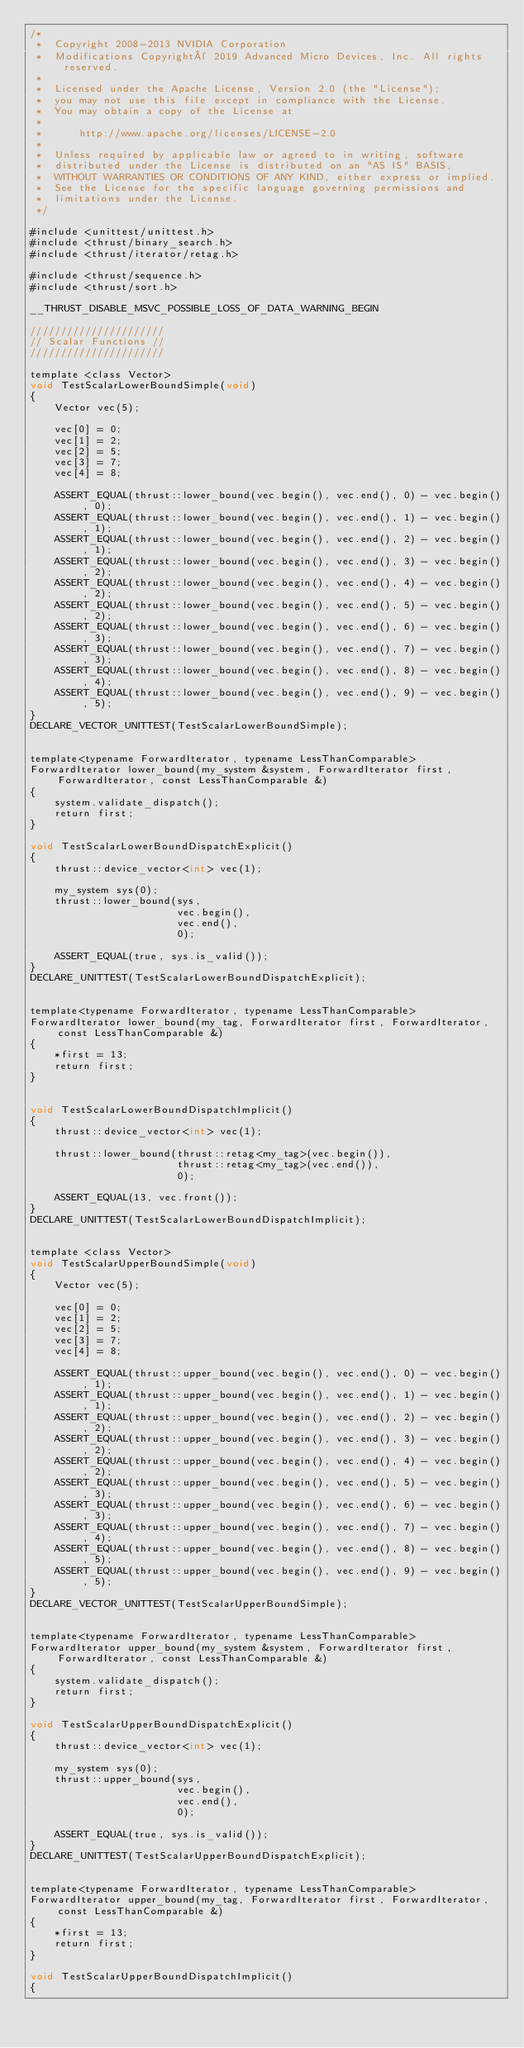Convert code to text. <code><loc_0><loc_0><loc_500><loc_500><_Cuda_>/*
 *  Copyright 2008-2013 NVIDIA Corporation
 *  Modifications Copyright© 2019 Advanced Micro Devices, Inc. All rights reserved.
 *
 *  Licensed under the Apache License, Version 2.0 (the "License");
 *  you may not use this file except in compliance with the License.
 *  You may obtain a copy of the License at
 *
 *      http://www.apache.org/licenses/LICENSE-2.0
 *
 *  Unless required by applicable law or agreed to in writing, software
 *  distributed under the License is distributed on an "AS IS" BASIS,
 *  WITHOUT WARRANTIES OR CONDITIONS OF ANY KIND, either express or implied.
 *  See the License for the specific language governing permissions and
 *  limitations under the License.
 */
 
#include <unittest/unittest.h>
#include <thrust/binary_search.h>
#include <thrust/iterator/retag.h>

#include <thrust/sequence.h>
#include <thrust/sort.h>

__THRUST_DISABLE_MSVC_POSSIBLE_LOSS_OF_DATA_WARNING_BEGIN

//////////////////////
// Scalar Functions //
//////////////////////

template <class Vector>
void TestScalarLowerBoundSimple(void)
{
    Vector vec(5);

    vec[0] = 0;
    vec[1] = 2;
    vec[2] = 5;
    vec[3] = 7;
    vec[4] = 8;

    ASSERT_EQUAL(thrust::lower_bound(vec.begin(), vec.end(), 0) - vec.begin(), 0);
    ASSERT_EQUAL(thrust::lower_bound(vec.begin(), vec.end(), 1) - vec.begin(), 1);
    ASSERT_EQUAL(thrust::lower_bound(vec.begin(), vec.end(), 2) - vec.begin(), 1);
    ASSERT_EQUAL(thrust::lower_bound(vec.begin(), vec.end(), 3) - vec.begin(), 2);
    ASSERT_EQUAL(thrust::lower_bound(vec.begin(), vec.end(), 4) - vec.begin(), 2);
    ASSERT_EQUAL(thrust::lower_bound(vec.begin(), vec.end(), 5) - vec.begin(), 2);
    ASSERT_EQUAL(thrust::lower_bound(vec.begin(), vec.end(), 6) - vec.begin(), 3);
    ASSERT_EQUAL(thrust::lower_bound(vec.begin(), vec.end(), 7) - vec.begin(), 3);
    ASSERT_EQUAL(thrust::lower_bound(vec.begin(), vec.end(), 8) - vec.begin(), 4);
    ASSERT_EQUAL(thrust::lower_bound(vec.begin(), vec.end(), 9) - vec.begin(), 5);
}
DECLARE_VECTOR_UNITTEST(TestScalarLowerBoundSimple);


template<typename ForwardIterator, typename LessThanComparable>
ForwardIterator lower_bound(my_system &system, ForwardIterator first, ForwardIterator, const LessThanComparable &)
{
    system.validate_dispatch();
    return first;
}

void TestScalarLowerBoundDispatchExplicit()
{
    thrust::device_vector<int> vec(1);

    my_system sys(0);
    thrust::lower_bound(sys,
                        vec.begin(),
                        vec.end(),
                        0);

    ASSERT_EQUAL(true, sys.is_valid());
}
DECLARE_UNITTEST(TestScalarLowerBoundDispatchExplicit);


template<typename ForwardIterator, typename LessThanComparable>
ForwardIterator lower_bound(my_tag, ForwardIterator first, ForwardIterator, const LessThanComparable &)
{
    *first = 13;
    return first;
}


void TestScalarLowerBoundDispatchImplicit()
{
    thrust::device_vector<int> vec(1);

    thrust::lower_bound(thrust::retag<my_tag>(vec.begin()),
                        thrust::retag<my_tag>(vec.end()),
                        0);

    ASSERT_EQUAL(13, vec.front());
}
DECLARE_UNITTEST(TestScalarLowerBoundDispatchImplicit);


template <class Vector>
void TestScalarUpperBoundSimple(void)
{
    Vector vec(5);

    vec[0] = 0;
    vec[1] = 2;
    vec[2] = 5;
    vec[3] = 7;
    vec[4] = 8;

    ASSERT_EQUAL(thrust::upper_bound(vec.begin(), vec.end(), 0) - vec.begin(), 1);
    ASSERT_EQUAL(thrust::upper_bound(vec.begin(), vec.end(), 1) - vec.begin(), 1);
    ASSERT_EQUAL(thrust::upper_bound(vec.begin(), vec.end(), 2) - vec.begin(), 2);
    ASSERT_EQUAL(thrust::upper_bound(vec.begin(), vec.end(), 3) - vec.begin(), 2);
    ASSERT_EQUAL(thrust::upper_bound(vec.begin(), vec.end(), 4) - vec.begin(), 2);
    ASSERT_EQUAL(thrust::upper_bound(vec.begin(), vec.end(), 5) - vec.begin(), 3);
    ASSERT_EQUAL(thrust::upper_bound(vec.begin(), vec.end(), 6) - vec.begin(), 3);
    ASSERT_EQUAL(thrust::upper_bound(vec.begin(), vec.end(), 7) - vec.begin(), 4);
    ASSERT_EQUAL(thrust::upper_bound(vec.begin(), vec.end(), 8) - vec.begin(), 5);
    ASSERT_EQUAL(thrust::upper_bound(vec.begin(), vec.end(), 9) - vec.begin(), 5);
}
DECLARE_VECTOR_UNITTEST(TestScalarUpperBoundSimple);


template<typename ForwardIterator, typename LessThanComparable>
ForwardIterator upper_bound(my_system &system, ForwardIterator first, ForwardIterator, const LessThanComparable &)
{
    system.validate_dispatch();
    return first;
}

void TestScalarUpperBoundDispatchExplicit()
{
    thrust::device_vector<int> vec(1);

    my_system sys(0);
    thrust::upper_bound(sys,
                        vec.begin(),
                        vec.end(),
                        0);

    ASSERT_EQUAL(true, sys.is_valid());
}
DECLARE_UNITTEST(TestScalarUpperBoundDispatchExplicit);


template<typename ForwardIterator, typename LessThanComparable>
ForwardIterator upper_bound(my_tag, ForwardIterator first, ForwardIterator, const LessThanComparable &)
{
    *first = 13;
    return first;
}

void TestScalarUpperBoundDispatchImplicit()
{</code> 